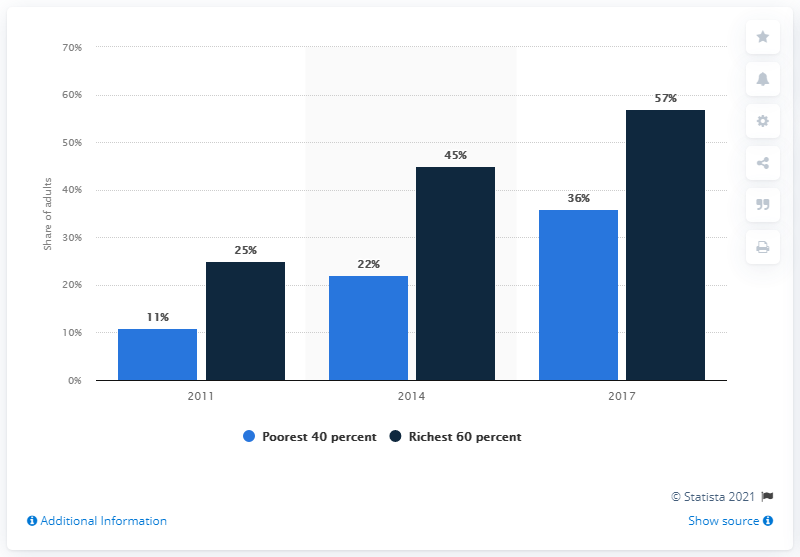Specify some key components in this picture. The average for 2014 is 33.5. The income level with the lowest values is the poorest 40 percent of the population. 